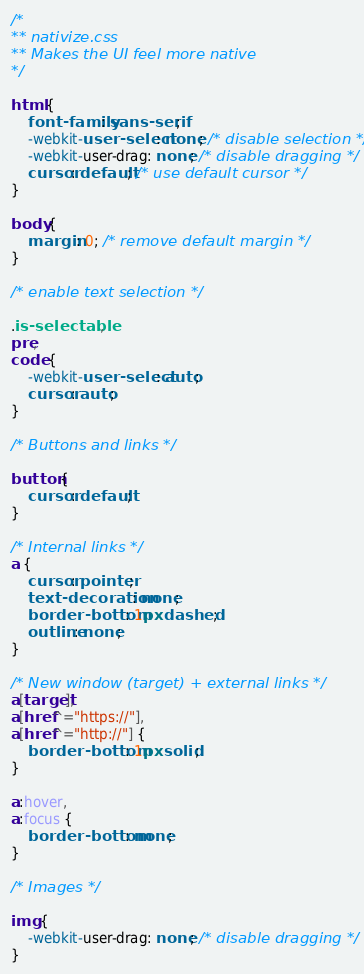<code> <loc_0><loc_0><loc_500><loc_500><_CSS_>/*
** nativize.css
** Makes the UI feel more native
*/

html {
    font-family: sans-serif;
    -webkit-user-select: none; /* disable selection */
    -webkit-user-drag: none; /* disable dragging */
    cursor: default; /* use default cursor */
}

body {
    margin: 0; /* remove default margin */
}

/* enable text selection */

.is-selectable,
pre,
code {
    -webkit-user-select: auto;
    cursor: auto;
}

/* Buttons and links */

button {
    cursor: default;
}

/* Internal links */
a {
    cursor: pointer;
    text-decoration: none;
    border-bottom: 1px dashed;
    outline: none;
}

/* New window (target) + external links */
a[target],
a[href^="https://"],
a[href^="http://"] {
    border-bottom: 1px solid;
}

a:hover,
a:focus {
    border-bottom: none;
}

/* Images */

img {
    -webkit-user-drag: none; /* disable dragging */
}
</code> 